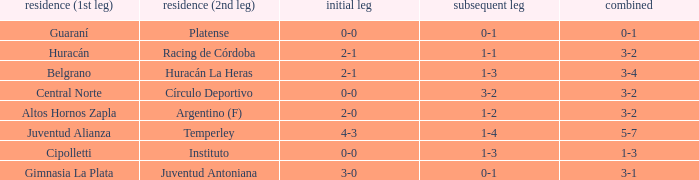Who played at home for the second leg with a score of 0-1 and tied 0-0 in the first leg? Platense. 